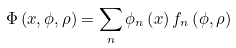<formula> <loc_0><loc_0><loc_500><loc_500>\Phi \left ( x , \phi , \rho \right ) = \sum _ { n } \phi _ { n } \left ( x \right ) f _ { n } \left ( \phi , \rho \right )</formula> 